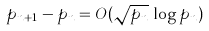<formula> <loc_0><loc_0><loc_500><loc_500>p _ { n + 1 } - p _ { n } = O ( { \sqrt { p _ { n } } } \, \log p _ { n } )</formula> 